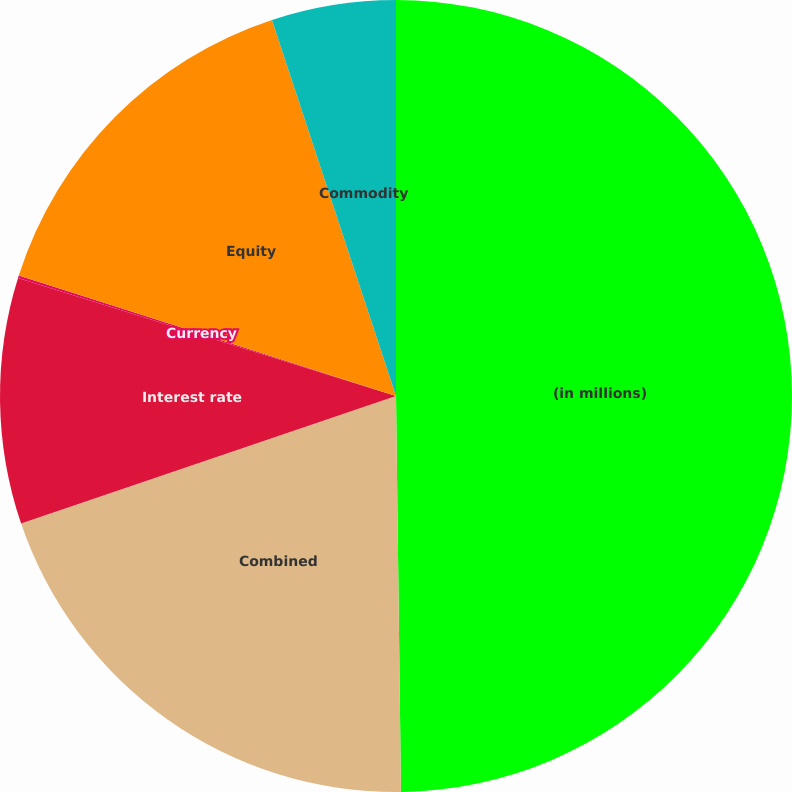Convert chart to OTSL. <chart><loc_0><loc_0><loc_500><loc_500><pie_chart><fcel>(in millions)<fcel>Combined<fcel>Interest rate<fcel>Currency<fcel>Equity<fcel>Commodity<nl><fcel>49.8%<fcel>19.98%<fcel>10.04%<fcel>0.1%<fcel>15.01%<fcel>5.07%<nl></chart> 